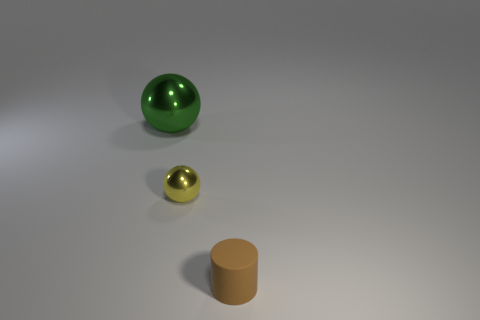Add 2 tiny yellow balls. How many objects exist? 5 Subtract 0 gray cylinders. How many objects are left? 3 Subtract all balls. How many objects are left? 1 Subtract 1 spheres. How many spheres are left? 1 Subtract all purple cylinders. Subtract all cyan balls. How many cylinders are left? 1 Subtract all purple balls. How many red cylinders are left? 0 Subtract all yellow shiny cylinders. Subtract all shiny objects. How many objects are left? 1 Add 2 small metallic objects. How many small metallic objects are left? 3 Add 1 small brown matte balls. How many small brown matte balls exist? 1 